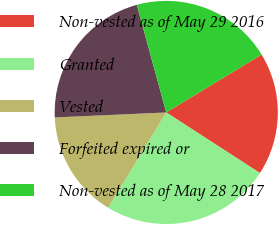Convert chart. <chart><loc_0><loc_0><loc_500><loc_500><pie_chart><fcel>Non-vested as of May 29 2016<fcel>Granted<fcel>Vested<fcel>Forfeited expired or<fcel>Non-vested as of May 28 2017<nl><fcel>17.82%<fcel>24.57%<fcel>15.58%<fcel>21.46%<fcel>20.56%<nl></chart> 